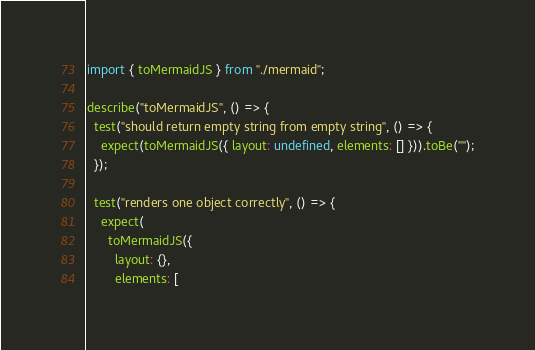<code> <loc_0><loc_0><loc_500><loc_500><_TypeScript_>import { toMermaidJS } from "./mermaid";

describe("toMermaidJS", () => {
  test("should return empty string from empty string", () => {
    expect(toMermaidJS({ layout: undefined, elements: [] })).toBe("");
  });

  test("renders one object correctly", () => {
    expect(
      toMermaidJS({
        layout: {},
        elements: [</code> 